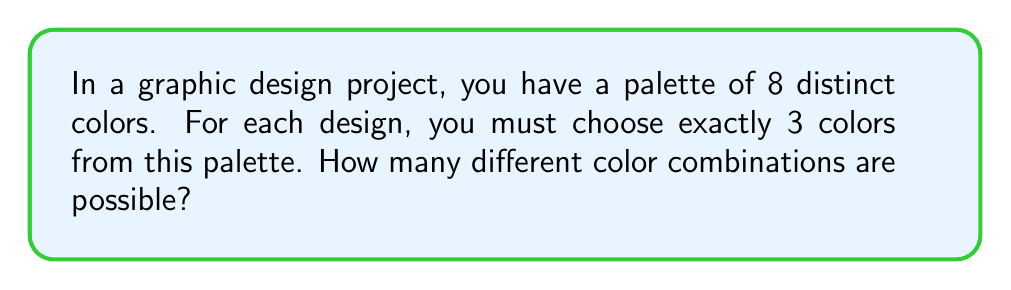Teach me how to tackle this problem. Let's approach this step-by-step:

1) This is a combination problem. We're selecting 3 colors from a set of 8, where the order doesn't matter (e.g., red-blue-green is the same combination as blue-green-red).

2) The formula for combinations is:

   $$C(n,r) = \frac{n!}{r!(n-r)!}$$

   Where $n$ is the total number of items to choose from, and $r$ is the number of items being chosen.

3) In this case, $n = 8$ (total colors) and $r = 3$ (colors chosen for each design).

4) Plugging these values into the formula:

   $$C(8,3) = \frac{8!}{3!(8-3)!} = \frac{8!}{3!5!}$$

5) Expand this:
   
   $$\frac{8 \times 7 \times 6 \times 5!}{(3 \times 2 \times 1) \times 5!}$$

6) The $5!$ cancels out in the numerator and denominator:

   $$\frac{8 \times 7 \times 6}{3 \times 2 \times 1} = \frac{336}{6} = 56$$

Therefore, there are 56 possible color combinations.
Answer: 56 